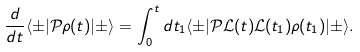<formula> <loc_0><loc_0><loc_500><loc_500>\frac { d } { d t } \langle \pm | { \mathcal { P } } \rho ( t ) | \pm \rangle = \int _ { 0 } ^ { t } d t _ { 1 } \langle \pm | { \mathcal { P } } { \mathcal { L } } ( t ) { \mathcal { L } } ( t _ { 1 } ) \rho ( t _ { 1 } ) | \pm \rangle .</formula> 